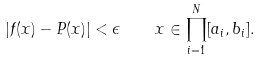<formula> <loc_0><loc_0><loc_500><loc_500>| f ( { x } ) - P ( { x } ) | < \epsilon \quad x \in \prod ^ { N } _ { i = 1 } [ a _ { i } , b _ { i } ] .</formula> 